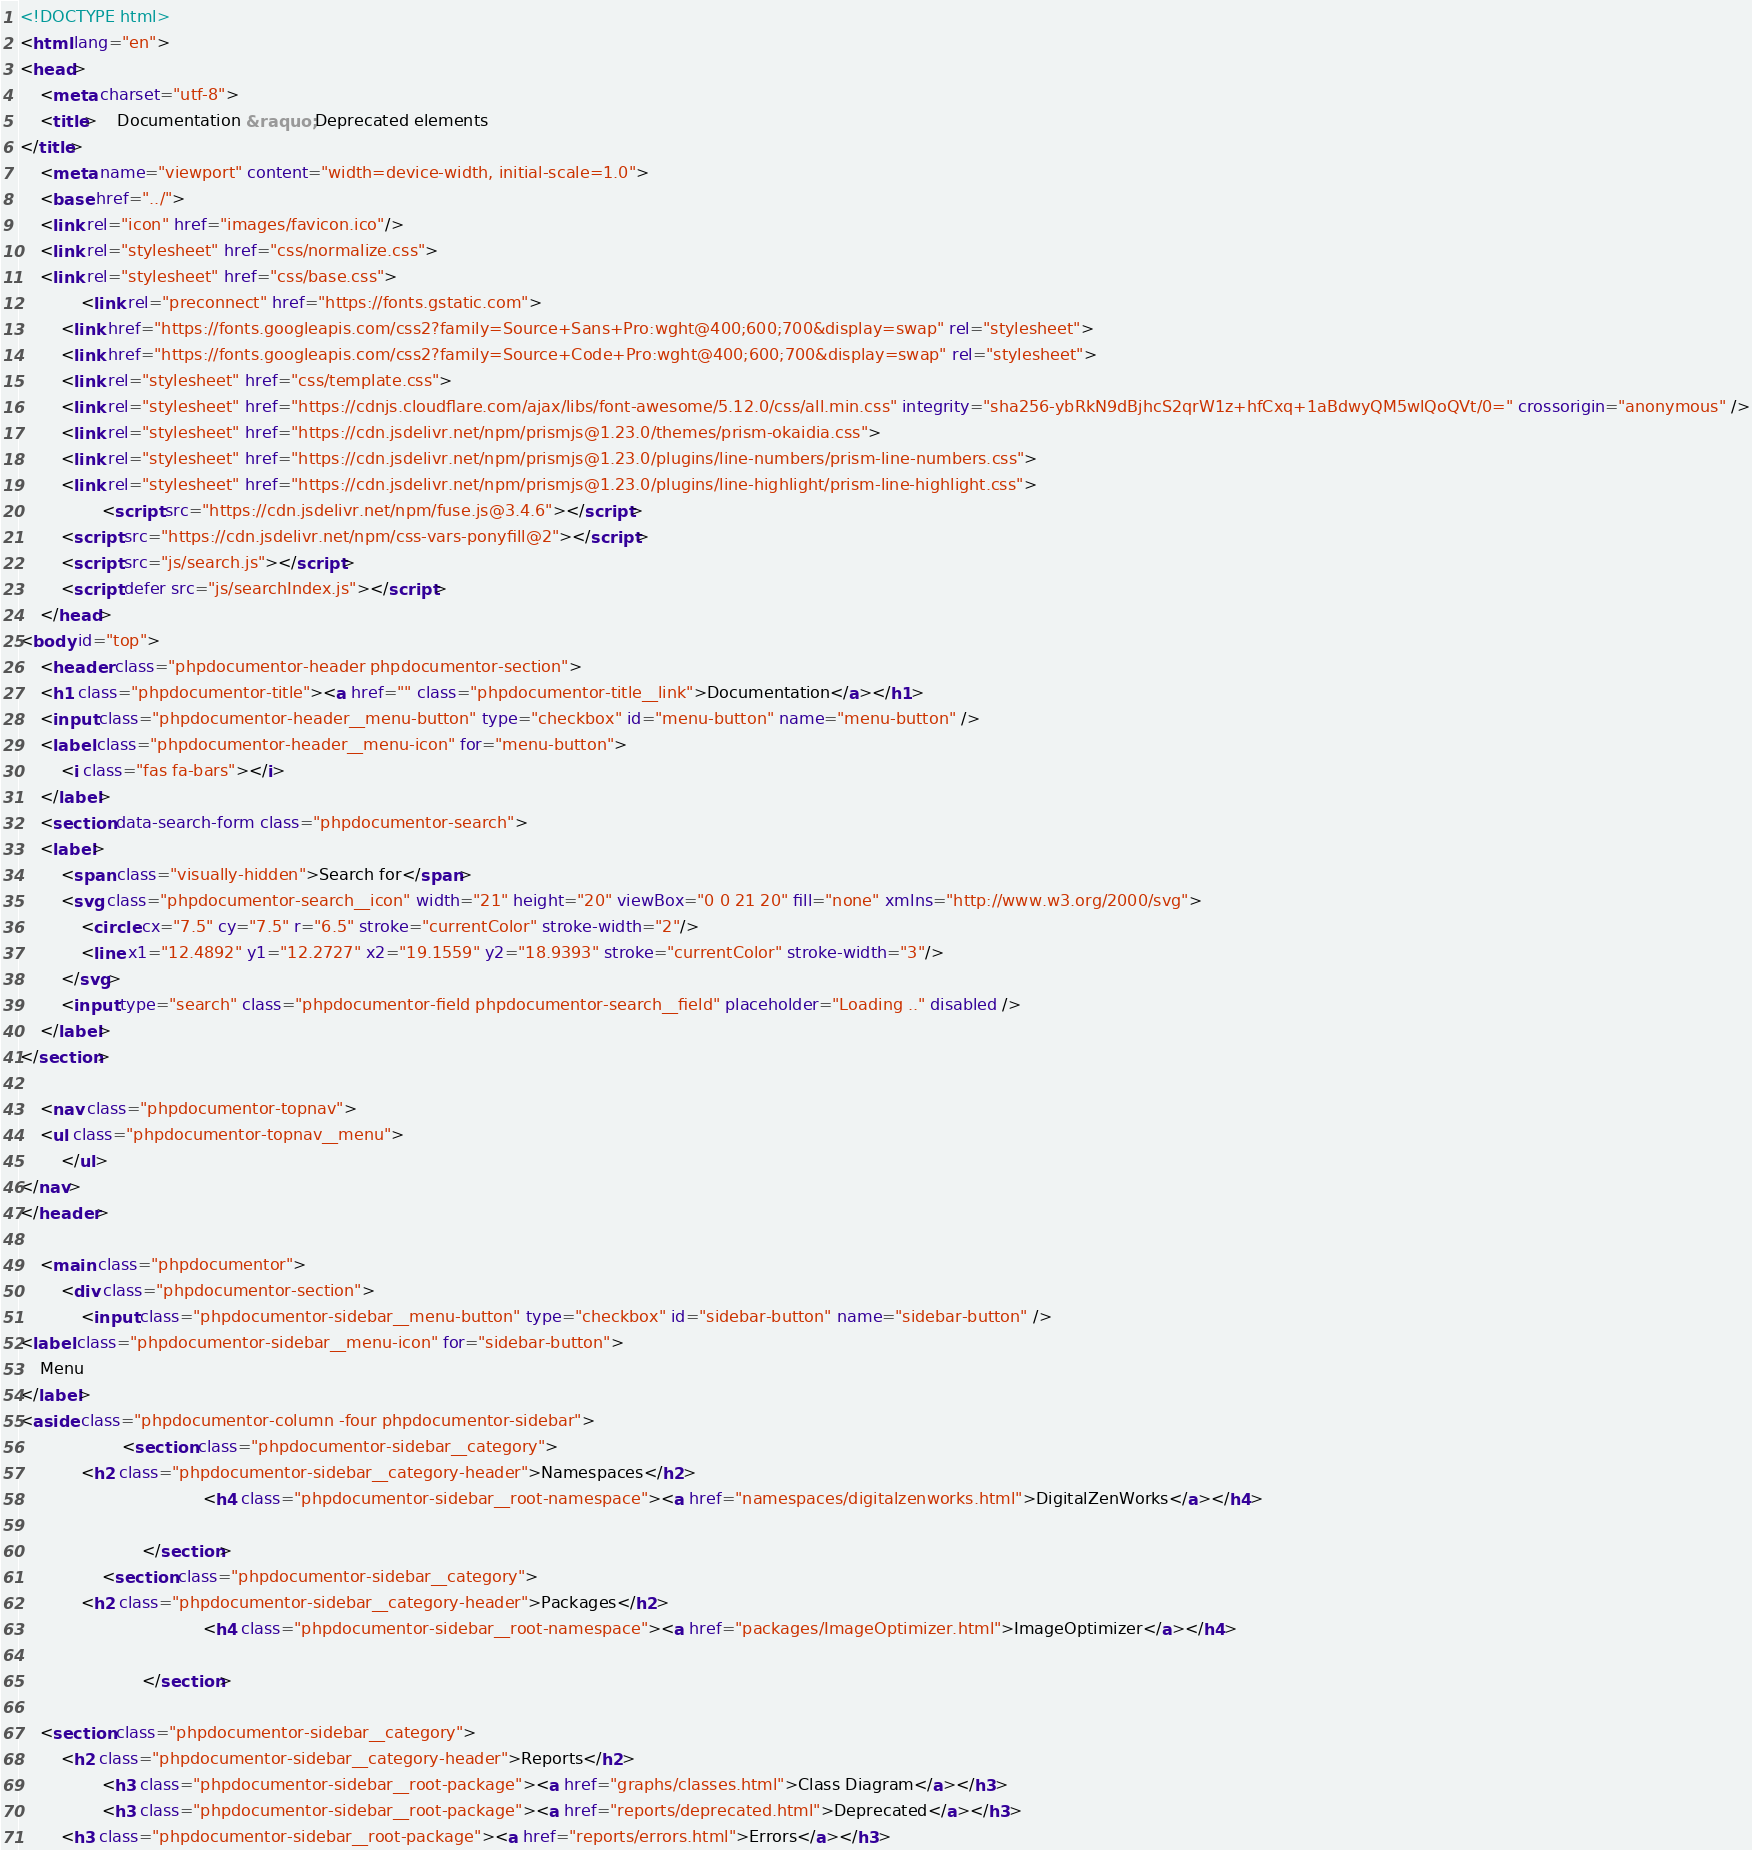Convert code to text. <code><loc_0><loc_0><loc_500><loc_500><_HTML_><!DOCTYPE html>
<html lang="en">
<head>
    <meta charset="utf-8">
    <title>    Documentation &raquo; Deprecated elements
</title>
    <meta name="viewport" content="width=device-width, initial-scale=1.0">
    <base href="../">
    <link rel="icon" href="images/favicon.ico"/>
    <link rel="stylesheet" href="css/normalize.css">
    <link rel="stylesheet" href="css/base.css">
            <link rel="preconnect" href="https://fonts.gstatic.com">
        <link href="https://fonts.googleapis.com/css2?family=Source+Sans+Pro:wght@400;600;700&display=swap" rel="stylesheet">
        <link href="https://fonts.googleapis.com/css2?family=Source+Code+Pro:wght@400;600;700&display=swap" rel="stylesheet">
        <link rel="stylesheet" href="css/template.css">
        <link rel="stylesheet" href="https://cdnjs.cloudflare.com/ajax/libs/font-awesome/5.12.0/css/all.min.css" integrity="sha256-ybRkN9dBjhcS2qrW1z+hfCxq+1aBdwyQM5wlQoQVt/0=" crossorigin="anonymous" />
        <link rel="stylesheet" href="https://cdn.jsdelivr.net/npm/prismjs@1.23.0/themes/prism-okaidia.css">
        <link rel="stylesheet" href="https://cdn.jsdelivr.net/npm/prismjs@1.23.0/plugins/line-numbers/prism-line-numbers.css">
        <link rel="stylesheet" href="https://cdn.jsdelivr.net/npm/prismjs@1.23.0/plugins/line-highlight/prism-line-highlight.css">
                <script src="https://cdn.jsdelivr.net/npm/fuse.js@3.4.6"></script>
        <script src="https://cdn.jsdelivr.net/npm/css-vars-ponyfill@2"></script>
        <script src="js/search.js"></script>
        <script defer src="js/searchIndex.js"></script>
    </head>
<body id="top">
    <header class="phpdocumentor-header phpdocumentor-section">
    <h1 class="phpdocumentor-title"><a href="" class="phpdocumentor-title__link">Documentation</a></h1>
    <input class="phpdocumentor-header__menu-button" type="checkbox" id="menu-button" name="menu-button" />
    <label class="phpdocumentor-header__menu-icon" for="menu-button">
        <i class="fas fa-bars"></i>
    </label>
    <section data-search-form class="phpdocumentor-search">
    <label>
        <span class="visually-hidden">Search for</span>
        <svg class="phpdocumentor-search__icon" width="21" height="20" viewBox="0 0 21 20" fill="none" xmlns="http://www.w3.org/2000/svg">
            <circle cx="7.5" cy="7.5" r="6.5" stroke="currentColor" stroke-width="2"/>
            <line x1="12.4892" y1="12.2727" x2="19.1559" y2="18.9393" stroke="currentColor" stroke-width="3"/>
        </svg>
        <input type="search" class="phpdocumentor-field phpdocumentor-search__field" placeholder="Loading .." disabled />
    </label>
</section>

    <nav class="phpdocumentor-topnav">
    <ul class="phpdocumentor-topnav__menu">
        </ul>
</nav>
</header>

    <main class="phpdocumentor">
        <div class="phpdocumentor-section">
            <input class="phpdocumentor-sidebar__menu-button" type="checkbox" id="sidebar-button" name="sidebar-button" />
<label class="phpdocumentor-sidebar__menu-icon" for="sidebar-button">
    Menu
</label>
<aside class="phpdocumentor-column -four phpdocumentor-sidebar">
                    <section class="phpdocumentor-sidebar__category">
            <h2 class="phpdocumentor-sidebar__category-header">Namespaces</h2>
                                    <h4 class="phpdocumentor-sidebar__root-namespace"><a href="namespaces/digitalzenworks.html">DigitalZenWorks</a></h4>

                        </section>
                <section class="phpdocumentor-sidebar__category">
            <h2 class="phpdocumentor-sidebar__category-header">Packages</h2>
                                    <h4 class="phpdocumentor-sidebar__root-namespace"><a href="packages/ImageOptimizer.html">ImageOptimizer</a></h4>

                        </section>
            
    <section class="phpdocumentor-sidebar__category">
        <h2 class="phpdocumentor-sidebar__category-header">Reports</h2>
                <h3 class="phpdocumentor-sidebar__root-package"><a href="graphs/classes.html">Class Diagram</a></h3>
                <h3 class="phpdocumentor-sidebar__root-package"><a href="reports/deprecated.html">Deprecated</a></h3>
        <h3 class="phpdocumentor-sidebar__root-package"><a href="reports/errors.html">Errors</a></h3></code> 